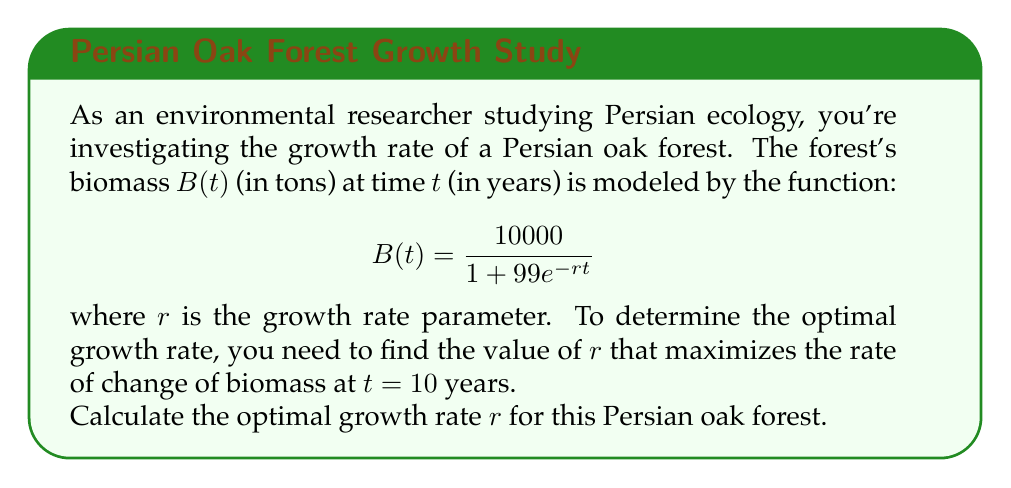Can you solve this math problem? To solve this problem, we'll follow these steps:

1) First, we need to find the derivative of $B(t)$ with respect to $t$:

   $$B'(t) = \frac{d}{dt}\left(\frac{10000}{1 + 99e^{-rt}}\right)$$
   
   Using the quotient rule, we get:
   
   $$B'(t) = \frac{10000 \cdot 99re^{-rt}}{(1 + 99e^{-rt})^2}$$

2) Now, we want to maximize $B'(t)$ at $t = 10$. Let's substitute $t = 10$ into our expression:

   $$B'(10) = \frac{990000re^{-10r}}{(1 + 99e^{-10r})^2}$$

3) To find the maximum, we need to differentiate this with respect to $r$ and set it equal to zero:

   $$\frac{d}{dr}B'(10) = \frac{990000e^{-10r}(1 + 99e^{-10r})^2 - 990000re^{-10r} \cdot 2(1 + 99e^{-10r})(-990e^{-10r})}{(1 + 99e^{-10r})^4} = 0$$

4) Simplifying this equation (multiply both sides by $(1 + 99e^{-10r})^3$):

   $$990000e^{-10r}(1 + 99e^{-10r}) + 1980000r \cdot 990e^{-20r} = 0$$

5) Further simplification:

   $$1 + 99e^{-10r} + 1980r \cdot 99e^{-10r} = 0$$
   
   $$1 + 99e^{-10r}(1 + 1980r) = 0$$

6) Solving this equation:

   $$99e^{-10r}(1 + 1980r) = -1$$
   
   $$e^{-10r}(1 + 1980r) = -\frac{1}{99}$$
   
   $$1 + 1980r = -\frac{e^{10r}}{99}$$
   
   $$1980r = -\frac{e^{10r}}{99} - 1$$
   
   $$r = -\frac{1}{1980}\left(\frac{e^{10r}}{99} + 1\right)$$

This equation cannot be solved analytically. We need to use numerical methods to find $r$. Using a numerical solver, we find that $r \approx 0.2303$.
Answer: $r \approx 0.2303$ year$^{-1}$ 